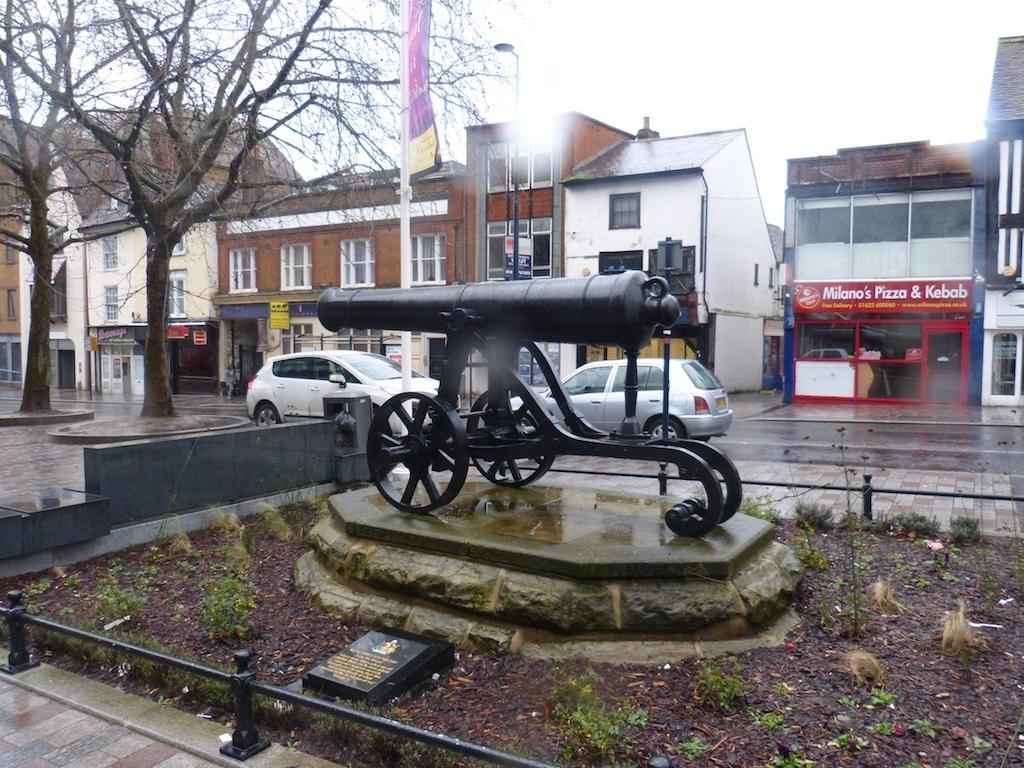What is the main subject of the sculpture in the image? There is a sculpture of a weapon in the image. What is the sculpture placed on? The sculpture is placed on a stone. What type of natural elements can be seen in the image? There are trees in the image. What man-made structures are visible in the image? There are vehicles and buildings in the image. Can you tell me how many times the earth is mentioned in the image? The term "earth" is not mentioned or depicted in the image. What type of drum is being played in the image? There is no drum present in the image. 